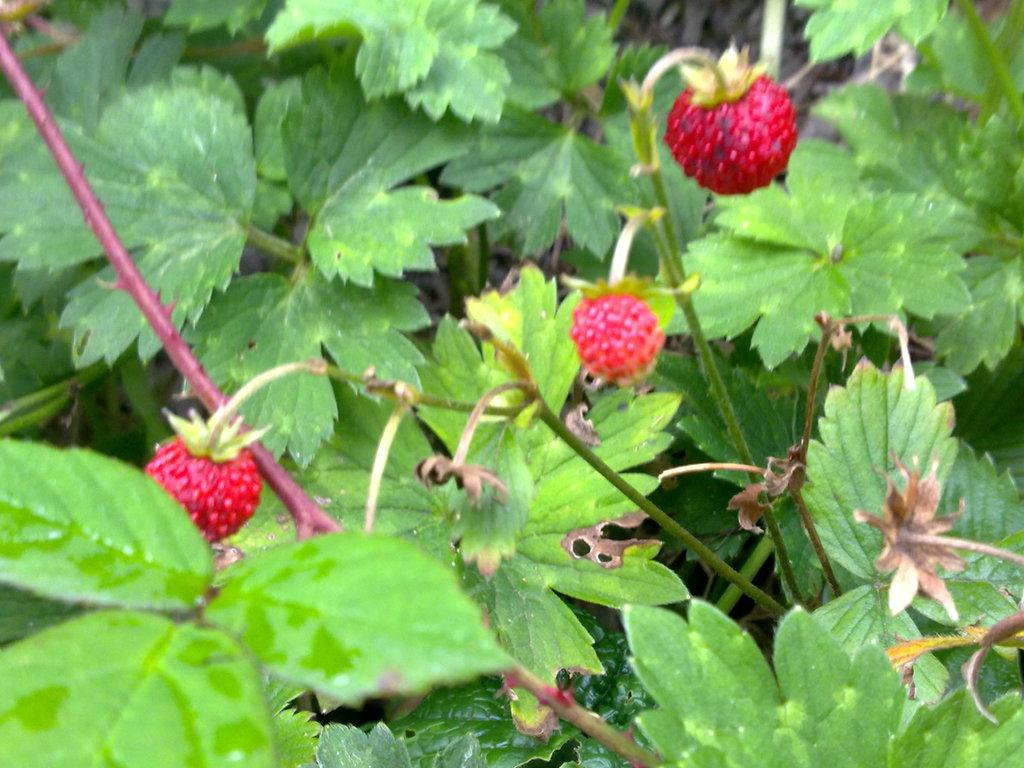What color are the fruits in the image? The fruits in the image are red. How many fruits are visible in the image? There are three fruits in the image. What can be seen in the background of the image? There are leaves in the background of the image. What type of flesh can be seen in the image? There is no flesh visible in the image; it features three red fruits and leaves in the background. 